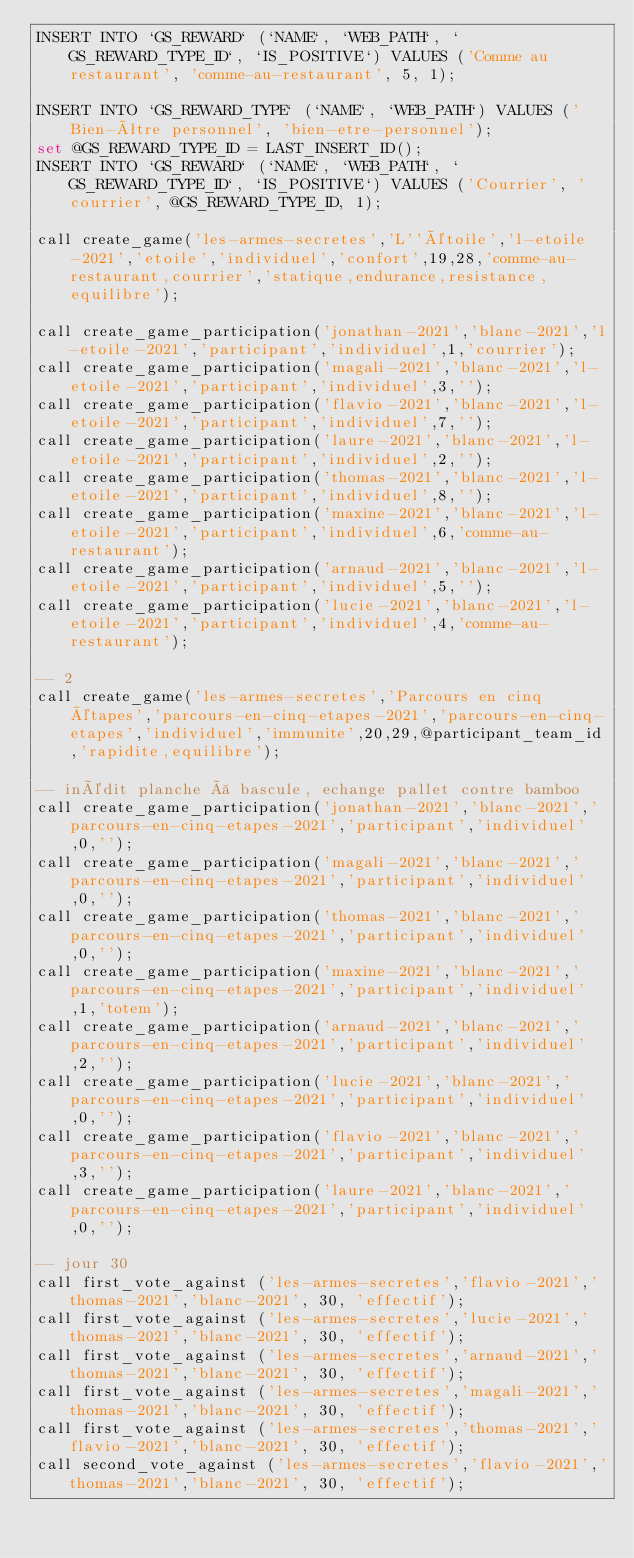<code> <loc_0><loc_0><loc_500><loc_500><_SQL_>INSERT INTO `GS_REWARD` (`NAME`, `WEB_PATH`, `GS_REWARD_TYPE_ID`, `IS_POSITIVE`) VALUES ('Comme au restaurant', 'comme-au-restaurant', 5, 1);

INSERT INTO `GS_REWARD_TYPE` (`NAME`, `WEB_PATH`) VALUES ('Bien-être personnel', 'bien-etre-personnel');
set @GS_REWARD_TYPE_ID = LAST_INSERT_ID();
INSERT INTO `GS_REWARD` (`NAME`, `WEB_PATH`, `GS_REWARD_TYPE_ID`, `IS_POSITIVE`) VALUES ('Courrier', 'courrier', @GS_REWARD_TYPE_ID, 1);

call create_game('les-armes-secretes','L''étoile','l-etoile-2021','etoile','individuel','confort',19,28,'comme-au-restaurant,courrier','statique,endurance,resistance,equilibre');

call create_game_participation('jonathan-2021','blanc-2021','l-etoile-2021','participant','individuel',1,'courrier');
call create_game_participation('magali-2021','blanc-2021','l-etoile-2021','participant','individuel',3,'');
call create_game_participation('flavio-2021','blanc-2021','l-etoile-2021','participant','individuel',7,'');
call create_game_participation('laure-2021','blanc-2021','l-etoile-2021','participant','individuel',2,'');
call create_game_participation('thomas-2021','blanc-2021','l-etoile-2021','participant','individuel',8,'');
call create_game_participation('maxine-2021','blanc-2021','l-etoile-2021','participant','individuel',6,'comme-au-restaurant');
call create_game_participation('arnaud-2021','blanc-2021','l-etoile-2021','participant','individuel',5,'');
call create_game_participation('lucie-2021','blanc-2021','l-etoile-2021','participant','individuel',4,'comme-au-restaurant');

-- 2 
call create_game('les-armes-secretes','Parcours en cinq étapes','parcours-en-cinq-etapes-2021','parcours-en-cinq-etapes','individuel','immunite',20,29,@participant_team_id,'rapidite,equilibre');

-- inédit planche à bascule, echange pallet contre bamboo
call create_game_participation('jonathan-2021','blanc-2021','parcours-en-cinq-etapes-2021','participant','individuel',0,'');
call create_game_participation('magali-2021','blanc-2021','parcours-en-cinq-etapes-2021','participant','individuel',0,'');
call create_game_participation('thomas-2021','blanc-2021','parcours-en-cinq-etapes-2021','participant','individuel',0,'');
call create_game_participation('maxine-2021','blanc-2021','parcours-en-cinq-etapes-2021','participant','individuel',1,'totem');
call create_game_participation('arnaud-2021','blanc-2021','parcours-en-cinq-etapes-2021','participant','individuel',2,'');
call create_game_participation('lucie-2021','blanc-2021','parcours-en-cinq-etapes-2021','participant','individuel',0,'');
call create_game_participation('flavio-2021','blanc-2021','parcours-en-cinq-etapes-2021','participant','individuel',3,'');
call create_game_participation('laure-2021','blanc-2021','parcours-en-cinq-etapes-2021','participant','individuel',0,'');

-- jour 30
call first_vote_against ('les-armes-secretes','flavio-2021','thomas-2021','blanc-2021', 30, 'effectif');
call first_vote_against ('les-armes-secretes','lucie-2021','thomas-2021','blanc-2021', 30, 'effectif');
call first_vote_against ('les-armes-secretes','arnaud-2021','thomas-2021','blanc-2021', 30, 'effectif');
call first_vote_against ('les-armes-secretes','magali-2021','thomas-2021','blanc-2021', 30, 'effectif');
call first_vote_against ('les-armes-secretes','thomas-2021','flavio-2021','blanc-2021', 30, 'effectif');
call second_vote_against ('les-armes-secretes','flavio-2021','thomas-2021','blanc-2021', 30, 'effectif');</code> 